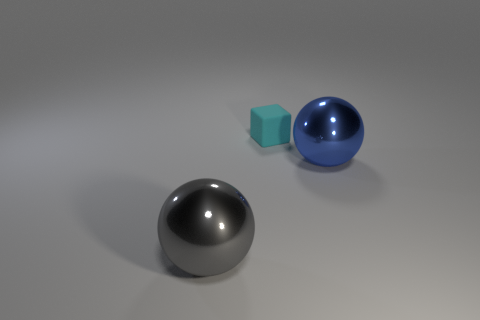Add 1 tiny purple cubes. How many objects exist? 4 Subtract all cubes. How many objects are left? 2 Subtract 0 cyan cylinders. How many objects are left? 3 Subtract all yellow matte things. Subtract all big blue objects. How many objects are left? 2 Add 2 big things. How many big things are left? 4 Add 1 rubber blocks. How many rubber blocks exist? 2 